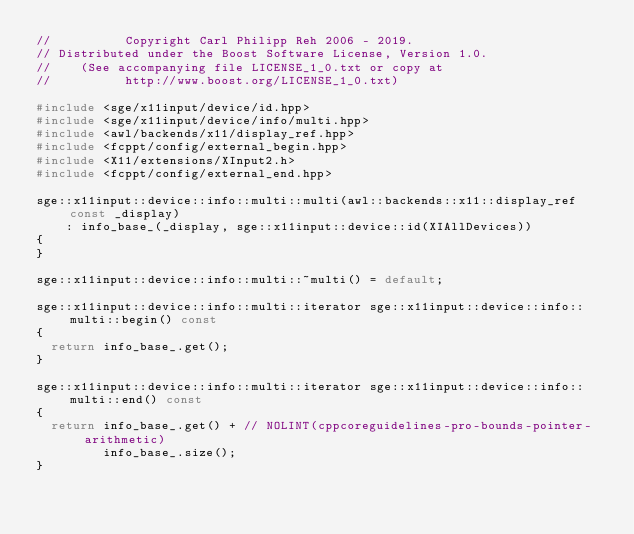<code> <loc_0><loc_0><loc_500><loc_500><_C++_>//          Copyright Carl Philipp Reh 2006 - 2019.
// Distributed under the Boost Software License, Version 1.0.
//    (See accompanying file LICENSE_1_0.txt or copy at
//          http://www.boost.org/LICENSE_1_0.txt)

#include <sge/x11input/device/id.hpp>
#include <sge/x11input/device/info/multi.hpp>
#include <awl/backends/x11/display_ref.hpp>
#include <fcppt/config/external_begin.hpp>
#include <X11/extensions/XInput2.h>
#include <fcppt/config/external_end.hpp>

sge::x11input::device::info::multi::multi(awl::backends::x11::display_ref const _display)
    : info_base_(_display, sge::x11input::device::id(XIAllDevices))
{
}

sge::x11input::device::info::multi::~multi() = default;

sge::x11input::device::info::multi::iterator sge::x11input::device::info::multi::begin() const
{
  return info_base_.get();
}

sge::x11input::device::info::multi::iterator sge::x11input::device::info::multi::end() const
{
  return info_base_.get() + // NOLINT(cppcoreguidelines-pro-bounds-pointer-arithmetic)
         info_base_.size();
}
</code> 